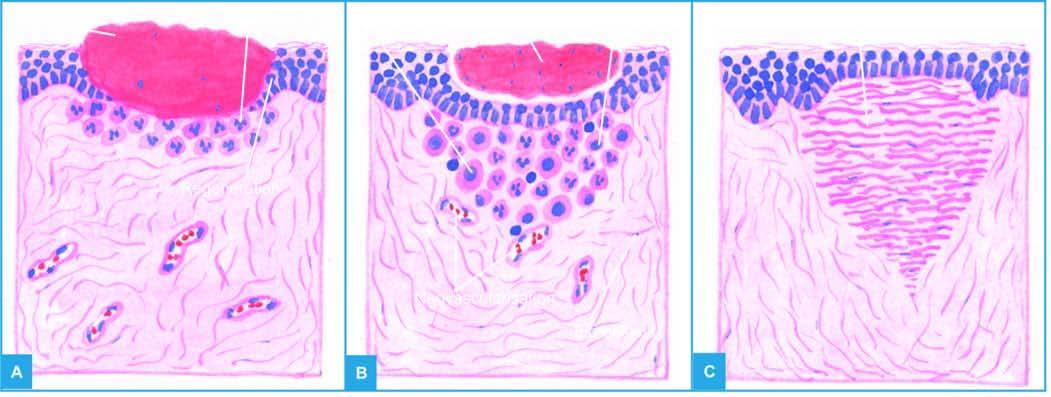s the open wound filled with blood clot?
Answer the question using a single word or phrase. Yes 